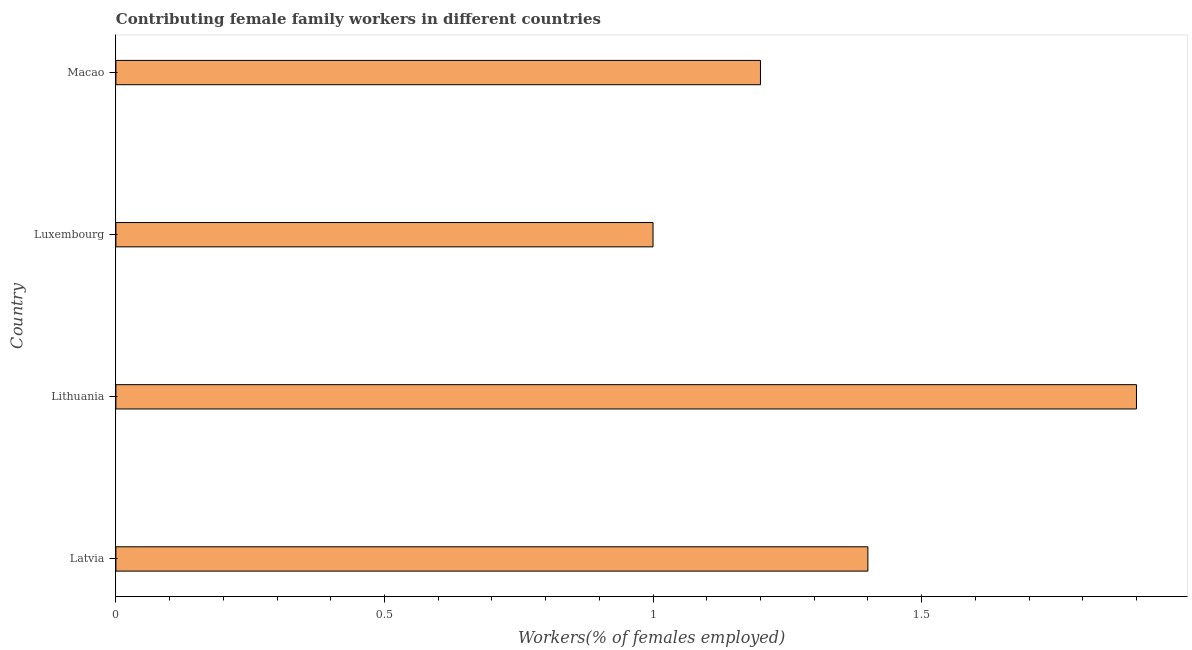Does the graph contain any zero values?
Keep it short and to the point. No. What is the title of the graph?
Keep it short and to the point. Contributing female family workers in different countries. What is the label or title of the X-axis?
Your response must be concise. Workers(% of females employed). What is the contributing female family workers in Macao?
Offer a very short reply. 1.2. Across all countries, what is the maximum contributing female family workers?
Offer a terse response. 1.9. Across all countries, what is the minimum contributing female family workers?
Offer a terse response. 1. In which country was the contributing female family workers maximum?
Ensure brevity in your answer.  Lithuania. In which country was the contributing female family workers minimum?
Offer a terse response. Luxembourg. What is the sum of the contributing female family workers?
Provide a short and direct response. 5.5. What is the average contributing female family workers per country?
Provide a succinct answer. 1.38. What is the median contributing female family workers?
Offer a terse response. 1.3. What is the ratio of the contributing female family workers in Latvia to that in Lithuania?
Your response must be concise. 0.74. Is the difference between the contributing female family workers in Latvia and Lithuania greater than the difference between any two countries?
Keep it short and to the point. No. What is the difference between the highest and the second highest contributing female family workers?
Your answer should be compact. 0.5. What is the difference between the highest and the lowest contributing female family workers?
Offer a terse response. 0.9. In how many countries, is the contributing female family workers greater than the average contributing female family workers taken over all countries?
Provide a short and direct response. 2. How many bars are there?
Ensure brevity in your answer.  4. How many countries are there in the graph?
Your answer should be very brief. 4. What is the difference between two consecutive major ticks on the X-axis?
Give a very brief answer. 0.5. Are the values on the major ticks of X-axis written in scientific E-notation?
Your answer should be compact. No. What is the Workers(% of females employed) of Latvia?
Give a very brief answer. 1.4. What is the Workers(% of females employed) of Lithuania?
Make the answer very short. 1.9. What is the Workers(% of females employed) of Luxembourg?
Ensure brevity in your answer.  1. What is the Workers(% of females employed) of Macao?
Give a very brief answer. 1.2. What is the difference between the Workers(% of females employed) in Latvia and Macao?
Provide a succinct answer. 0.2. What is the difference between the Workers(% of females employed) in Lithuania and Luxembourg?
Offer a very short reply. 0.9. What is the difference between the Workers(% of females employed) in Luxembourg and Macao?
Make the answer very short. -0.2. What is the ratio of the Workers(% of females employed) in Latvia to that in Lithuania?
Make the answer very short. 0.74. What is the ratio of the Workers(% of females employed) in Latvia to that in Luxembourg?
Provide a succinct answer. 1.4. What is the ratio of the Workers(% of females employed) in Latvia to that in Macao?
Ensure brevity in your answer.  1.17. What is the ratio of the Workers(% of females employed) in Lithuania to that in Macao?
Provide a succinct answer. 1.58. What is the ratio of the Workers(% of females employed) in Luxembourg to that in Macao?
Your answer should be compact. 0.83. 